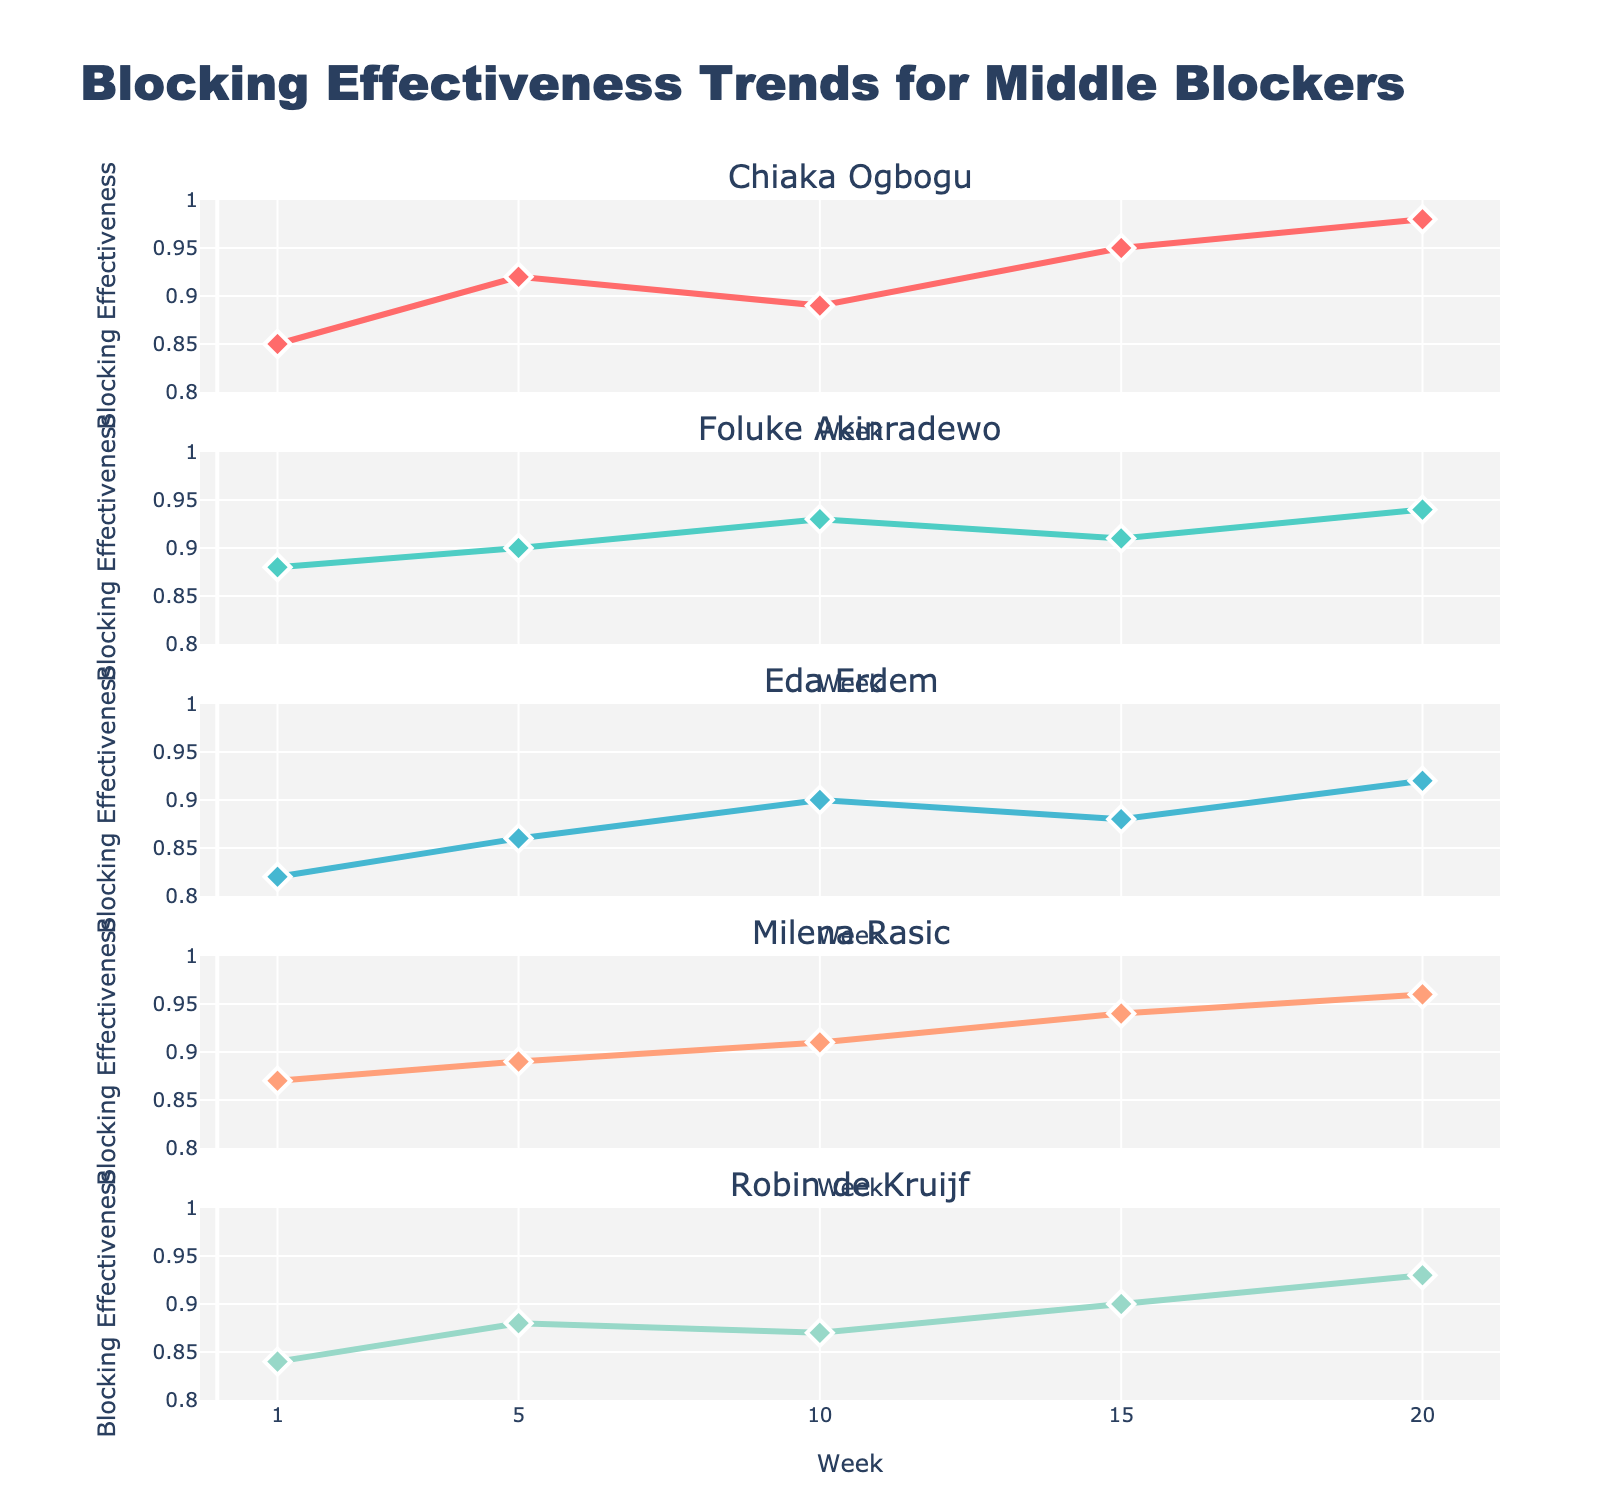What does the title of the figure say? The title at the top of the figure reads "Employee Retention Analysis" in larger font, indicating the overall subject of the figure.
Answer: Employee Retention Analysis What trend do you observe for FlexiTech Solutions in the scatter plot over the years? In the scatter plot, the retention rate for employees pursuing education at FlexiTech Solutions shows a consistent increase from 92% in 2018 to 97% in 2022.
Answer: Increasing trend Which company has the highest average retention rate for employees pursuing education in the bar plot? By examining the bar plot, FlexiTech Solutions has the highest average retention rate for employees pursuing education, which is around 94.8%.
Answer: FlexiTech Solutions What is the difference in the average retention rates for employees pursuing vs. not pursuing education at LearnWell Manufacturing? In the bar plot, the average retention rate for employees pursuing education at LearnWell Manufacturing is about 90.6%, while for those not pursuing education is approximately 82%. The difference is 90.6% - 82% = 8.6%.
Answer: 8.6% Which industry has the highest median retention rate for employees not pursuing education in the box plot? The box plot shows that the technology industry has the highest median retention rate for employees not pursuing education, which is roughly around 87%.
Answer: Technology What is the retention rate for EduCare Health in 2022 shown in the heatmap for employees pursuing education? In the heatmap, by locating the intersection of EduCare Health and the year 2022, the retention rate for employees pursuing education is found to be 95%.
Answer: 95% How do retention rates of employees pursuing education compare to those not pursuing at FlexiTech Solutions throughout the years? In both the scatter plot and bar plot, the retention rates for employees pursuing education at FlexiTech Solutions are consistently higher than those not pursuing education. The difference ranges from 5% to 8% each year.
Answer: Higher for pursuing education What is the retention rate in 2020 for employees not pursuing education at GrowthMind Retail? In the scatter plot, by looking at the line corresponding to GrowthMind Retail for the year 2020, the retention rate for employees not pursuing education is found to be 80%.
Answer: 80% Which company shows the largest year-on-year increase in retention rates for employees pursuing education in the scatter plot? From the scatter plot, by comparing year-on-year increases, FlexiTech Solutions shows the largest consistent increase year-on-year, peaking at 1% from 2021 to 2022.
Answer: FlexiTech Solutions 